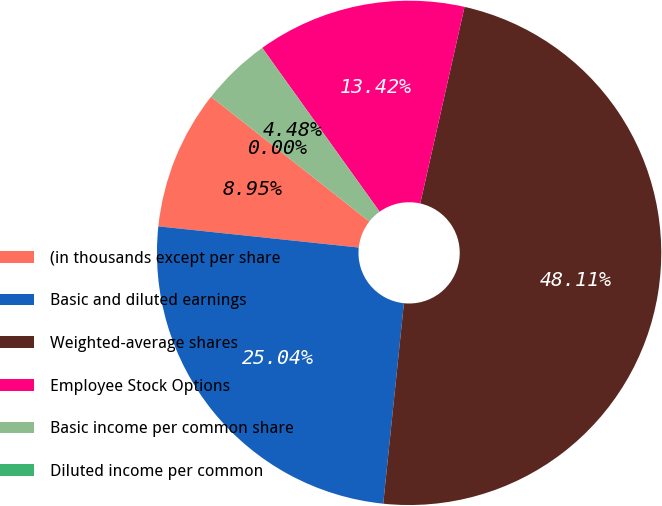Convert chart. <chart><loc_0><loc_0><loc_500><loc_500><pie_chart><fcel>(in thousands except per share<fcel>Basic and diluted earnings<fcel>Weighted-average shares<fcel>Employee Stock Options<fcel>Basic income per common share<fcel>Diluted income per common<nl><fcel>8.95%<fcel>25.04%<fcel>48.11%<fcel>13.42%<fcel>4.48%<fcel>0.0%<nl></chart> 